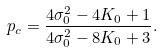<formula> <loc_0><loc_0><loc_500><loc_500>p _ { c } = \frac { 4 \sigma ^ { 2 } _ { 0 } - 4 K _ { 0 } + 1 } { 4 \sigma ^ { 2 } _ { 0 } - 8 K _ { 0 } + 3 } .</formula> 